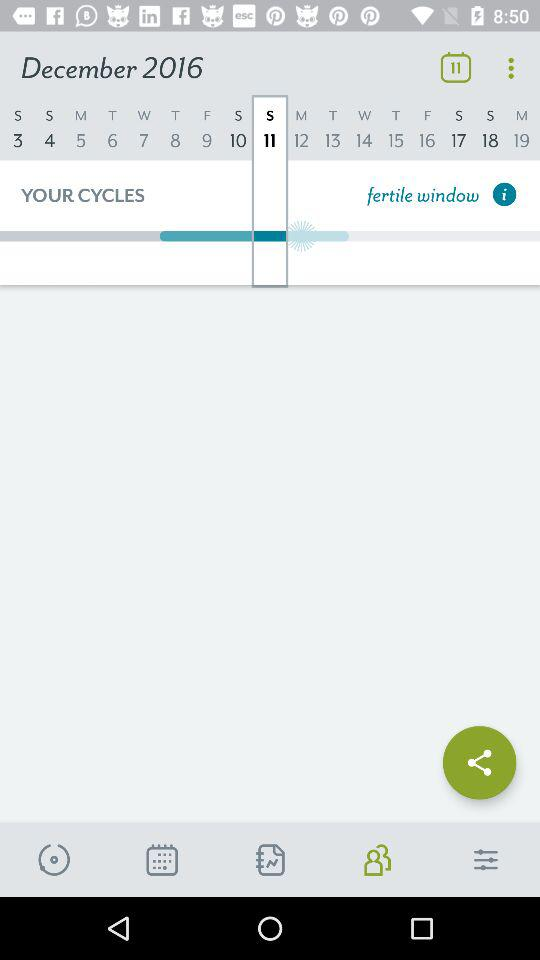Which date is selected? The selected date is Sunday, December 11, 2016. 